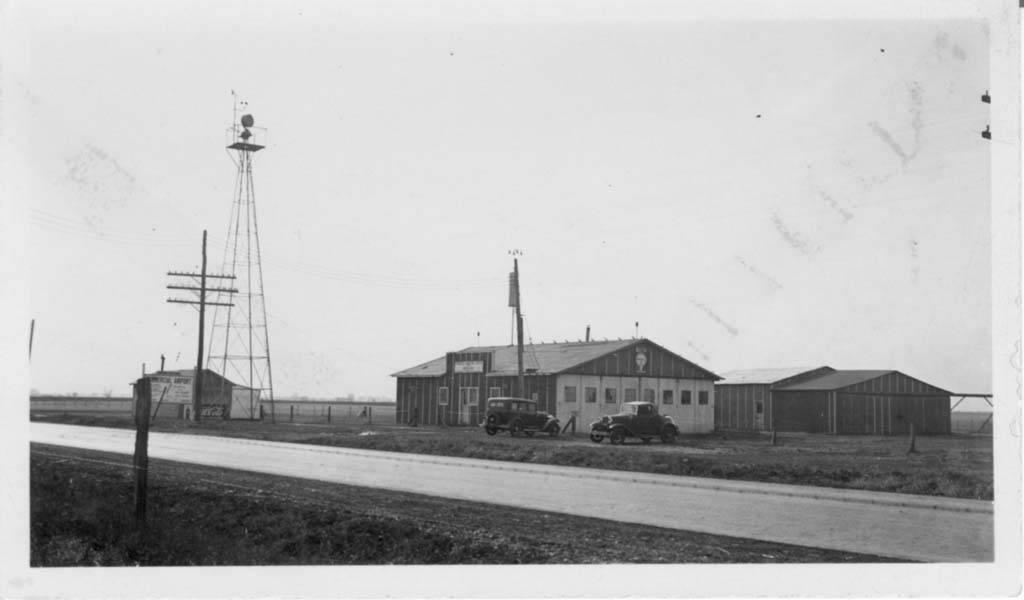What is the color scheme of the image? The image is black and white. What is the main feature of the image? There is a road in the image. What can be seen on either side of the road? On either side of the road, there is land. What is visible in the background of the image? A: In the background of the image, there are cars, houses, poles, and the sky. What historical event is being commemorated by the mind in the image? There is no mention of a mind or historical event in the image; it features a road, land, cars, houses, poles, and the sky. 